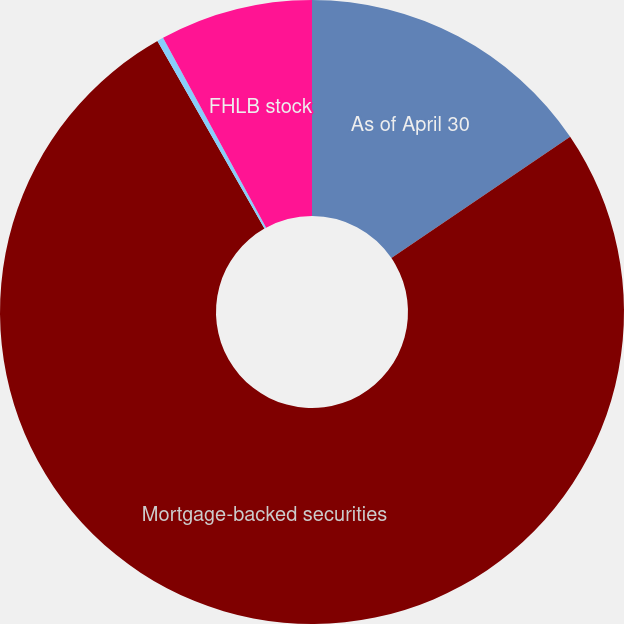<chart> <loc_0><loc_0><loc_500><loc_500><pie_chart><fcel>As of April 30<fcel>Mortgage-backed securities<fcel>Federal funds sold<fcel>FHLB stock<nl><fcel>15.51%<fcel>76.24%<fcel>0.33%<fcel>7.92%<nl></chart> 